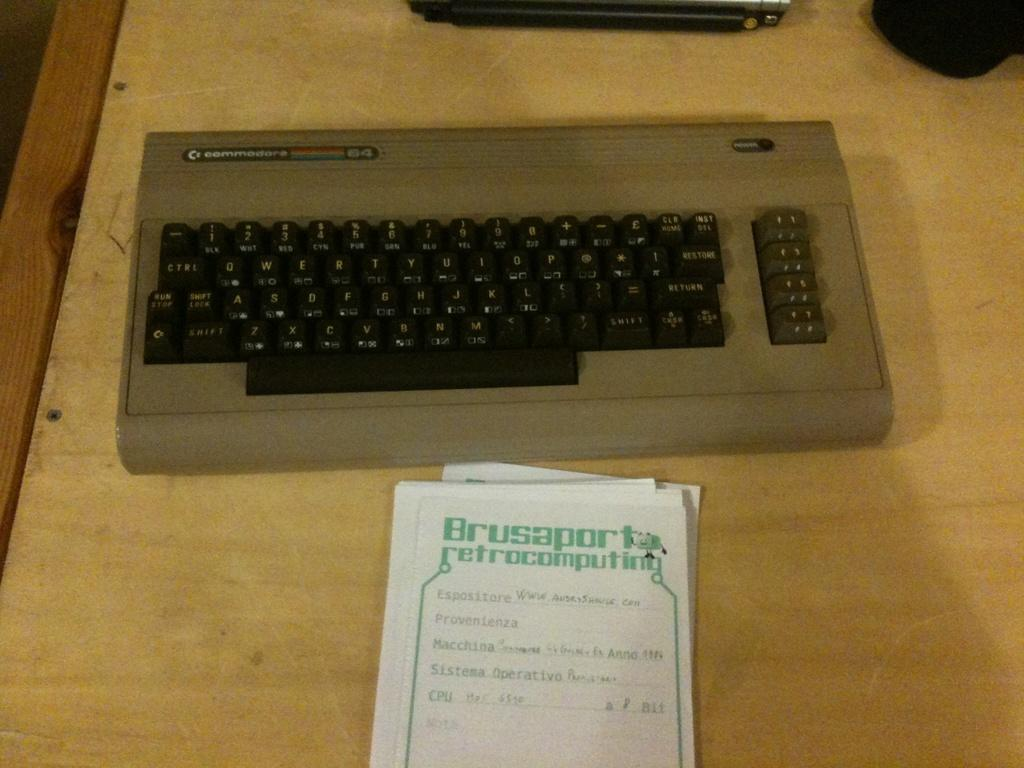<image>
Provide a brief description of the given image. An old commodor keyboard in front of a piece of paper that says Brusaporta retrocomputing. 